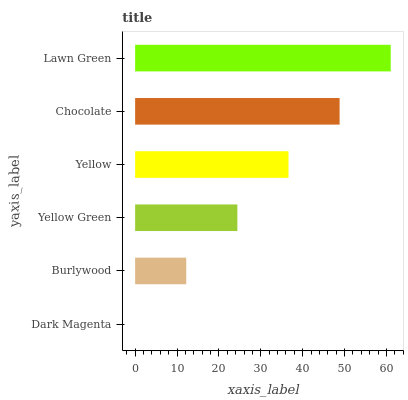Is Dark Magenta the minimum?
Answer yes or no. Yes. Is Lawn Green the maximum?
Answer yes or no. Yes. Is Burlywood the minimum?
Answer yes or no. No. Is Burlywood the maximum?
Answer yes or no. No. Is Burlywood greater than Dark Magenta?
Answer yes or no. Yes. Is Dark Magenta less than Burlywood?
Answer yes or no. Yes. Is Dark Magenta greater than Burlywood?
Answer yes or no. No. Is Burlywood less than Dark Magenta?
Answer yes or no. No. Is Yellow the high median?
Answer yes or no. Yes. Is Yellow Green the low median?
Answer yes or no. Yes. Is Dark Magenta the high median?
Answer yes or no. No. Is Lawn Green the low median?
Answer yes or no. No. 